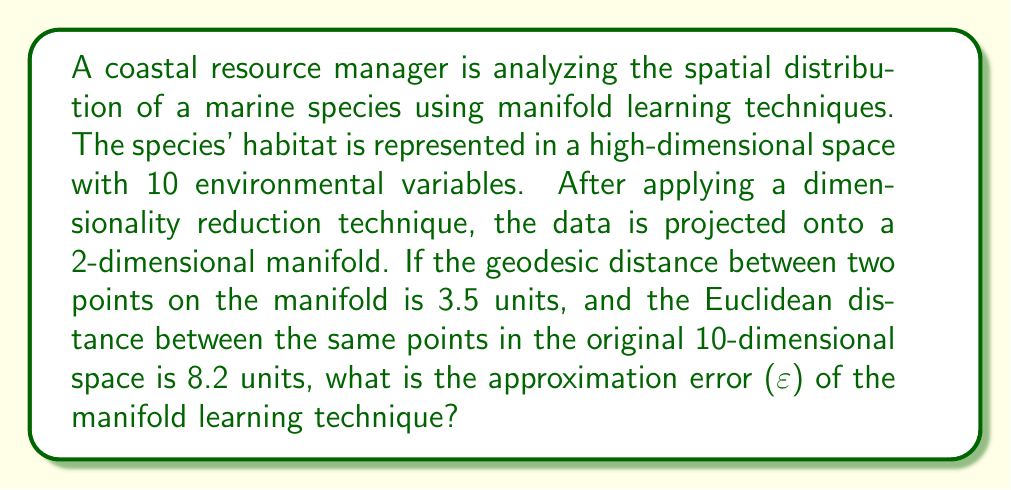Can you answer this question? To solve this problem, we need to understand the concept of approximation error in manifold learning techniques. The approximation error (ε) measures how well the lower-dimensional manifold preserves the distances between points in the original high-dimensional space.

Let's define:
- $d_G$: Geodesic distance on the manifold
- $d_E$: Euclidean distance in the original space
- ε: Approximation error

The approximation error can be calculated using the following formula:

$$ \varepsilon = \left|\frac{d_G - d_E}{d_E}\right| $$

This formula gives us the relative difference between the geodesic distance on the manifold and the Euclidean distance in the original space.

Given:
- $d_G = 3.5$ units
- $d_E = 8.2$ units

Let's substitute these values into the formula:

$$ \varepsilon = \left|\frac{3.5 - 8.2}{8.2}\right| $$

$$ \varepsilon = \left|\frac{-4.7}{8.2}\right| $$

$$ \varepsilon = \frac{4.7}{8.2} $$

$$ \varepsilon \approx 0.5732 $$

Converting to a percentage:

$$ \varepsilon \approx 57.32\% $$

This means that the manifold learning technique has an approximation error of about 57.32% in preserving the distance between these two points.
Answer: The approximation error (ε) of the manifold learning technique is approximately 0.5732 or 57.32%. 